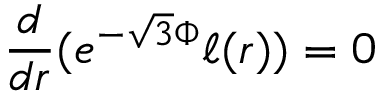Convert formula to latex. <formula><loc_0><loc_0><loc_500><loc_500>\frac { d } { d r } ( e ^ { - \sqrt { 3 } \Phi } \ell ( r ) ) = 0</formula> 